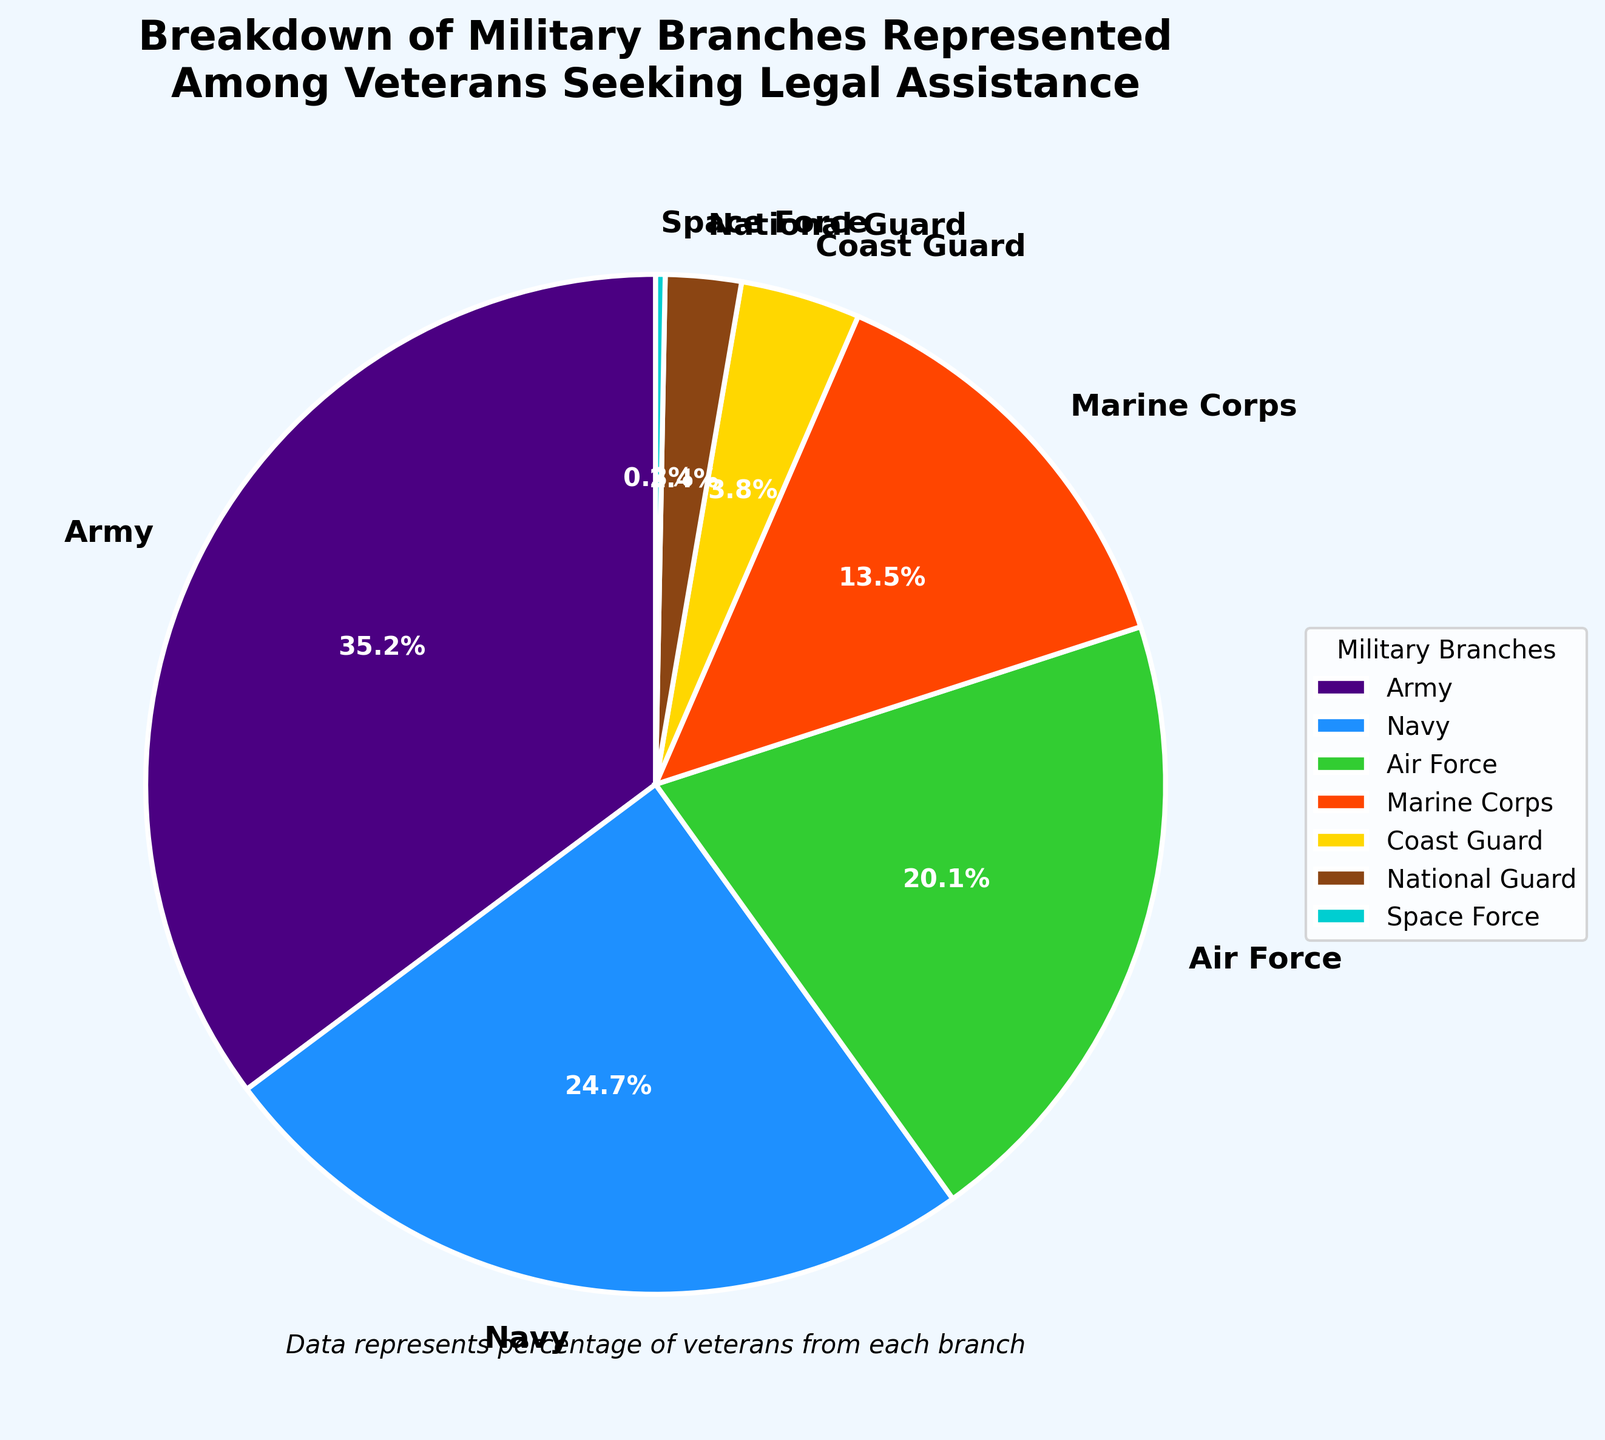What percentage of veterans seeking legal assistance come from the Army? The pie chart shows the breakdown of military branches represented among veterans seeking legal assistance. By looking at the segment for the Army, we see a percentage. The Army has 35.2% representation.
Answer: 35.2% Which branch has the least representation among veterans seeking legal assistance? By examining the pie chart, the segment with the smallest slice is for the Space Force. It shows 0.3% representation.
Answer: Space Force How does the percentage of Navy veterans compare to Air Force veterans seeking legal assistance? We look at the segments for the Navy and the Air Force. The Navy has 24.7%, and the Air Force has 20.1%. Since 24.7% is greater than 20.1%, the Navy has a higher percentage than the Air Force.
Answer: Navy > Air Force What is the combined percentage of veterans from the Army, Navy, and Air Force? To find the combined percentage, we add the percentages for the Army (35.2), Navy (24.7), and Air Force (20.1). The sum is 35.2 + 24.7 + 20.1 = 80.0%.
Answer: 80.0% Which branch has nearly three times the representation as the Marine Corps? We first identify the percentage for the Marine Corps, which is 13.5%. Three times this would be approximately 40.5%. The Army has 35.2%, which is closest to this value.
Answer: Army Arrange the branches in descending order based on their representation percentage. We read the percentages from the chart: Army (35.2%), Navy (24.7%), Air Force (20.1%), Marine Corps (13.5%), Coast Guard (3.8%), National Guard (2.4%), Space Force (0.3%).
Answer: Army, Navy, Air Force, Marine Corps, Coast Guard, National Guard, Space Force Which branch's segment is colored red in the pie chart? From the described colors for the chart, the red color (#FF4500) is used for a specific branch. By matching it, we identify the Marine Corps.
Answer: Marine Corps If we combined the percentages of the Coast Guard, National Guard, and Space Force, would their total be more than 10%? We add the percentages for the Coast Guard (3.8%), National Guard (2.4%), and Space Force (0.3%). The sum is 3.8 + 2.4 + 0.3 = 6.5%, which is not greater than 10%.
Answer: No Is the percentage of Marine Corps veterans seeking legal assistance greater or lower than double the percentage of National Guard veterans? We double the percentage for the National Guard (2.4 * 2 = 4.8%). The Marine Corps has 13.5%, which is greater than 4.8%.
Answer: Greater What is the average representation percentage of the National Guard and the Space Force? To find the average, we add their percentages and divide by 2. (2.4 + 0.3) / 2 = 1.35%.
Answer: 1.35% 